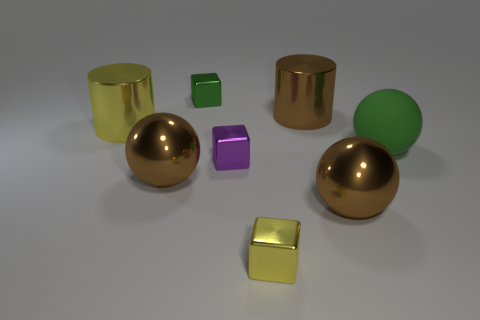There is a block that is the same color as the rubber sphere; what is it made of?
Your answer should be very brief. Metal. How many other things have the same shape as the large green matte thing?
Your answer should be very brief. 2. What shape is the small yellow metal thing?
Give a very brief answer. Cube. Is the number of large matte things less than the number of brown metallic spheres?
Make the answer very short. Yes. What is the material of the small purple thing that is the same shape as the tiny yellow metallic object?
Make the answer very short. Metal. Are there more big cyan metal spheres than yellow things?
Make the answer very short. No. What number of other objects are there of the same color as the large matte object?
Your answer should be very brief. 1. Are the large yellow cylinder and the brown sphere that is on the left side of the green block made of the same material?
Provide a short and direct response. Yes. How many big rubber things are in front of the metal sphere left of the shiny block that is behind the big yellow shiny object?
Your response must be concise. 0. Are there fewer small green metallic things in front of the purple metallic cube than large yellow metal cylinders left of the large matte object?
Ensure brevity in your answer.  Yes. 